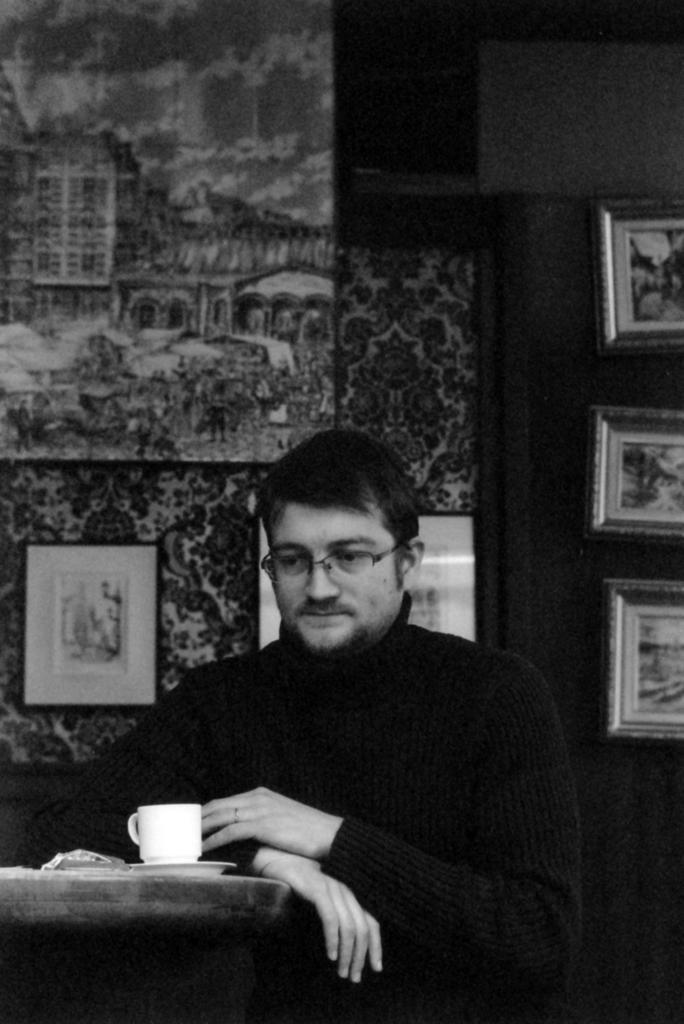Please provide a concise description of this image. In this image we can see a man and cup on the table in front of the man. In the background we can see wall with wallpapers and wall hangings attached to it. 